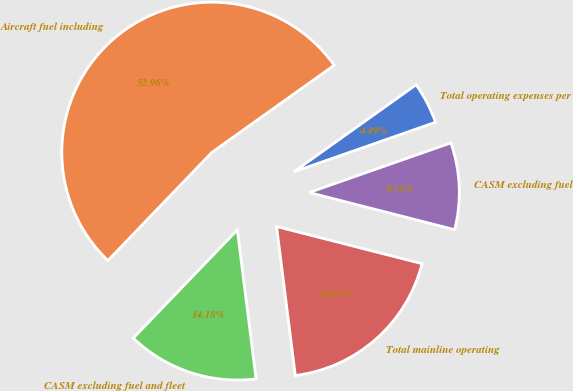Convert chart to OTSL. <chart><loc_0><loc_0><loc_500><loc_500><pie_chart><fcel>Total operating expenses per<fcel>Aircraft fuel including<fcel>CASM excluding fuel and fleet<fcel>Total mainline operating<fcel>CASM excluding fuel<nl><fcel>4.49%<fcel>52.96%<fcel>14.18%<fcel>19.03%<fcel>9.34%<nl></chart> 